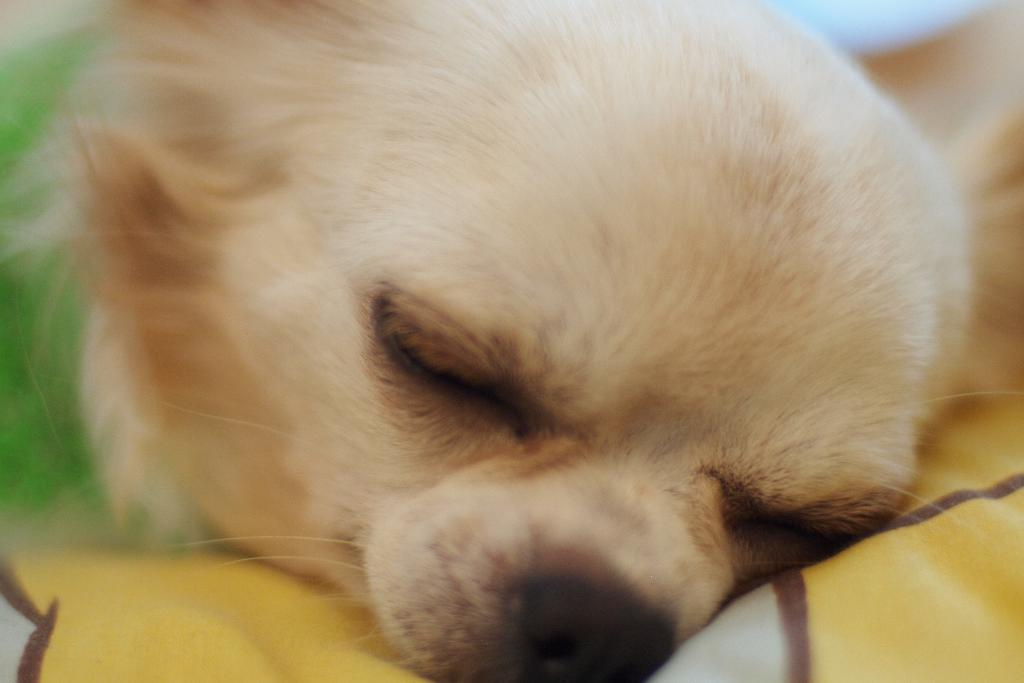What type of animal is in the image? There is a dog in the image. What is the dog doing in the image? The dog is sleeping. Where is the bucket located in the image? There is no bucket present in the image. How many family members are visible in the image? There are no family members visible in the image; only the dog is present. 